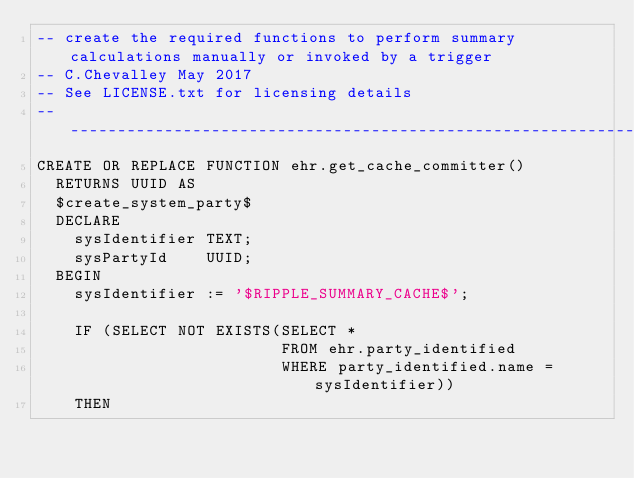Convert code to text. <code><loc_0><loc_0><loc_500><loc_500><_SQL_>-- create the required functions to perform summary calculations manually or invoked by a trigger
-- C.Chevalley May 2017
-- See LICENSE.txt for licensing details
-------------------------------------------------------------------------------------------------
CREATE OR REPLACE FUNCTION ehr.get_cache_committer()
  RETURNS UUID AS
  $create_system_party$
  DECLARE
    sysIdentifier TEXT;
    sysPartyId    UUID;
  BEGIN
    sysIdentifier := '$RIPPLE_SUMMARY_CACHE$';

    IF (SELECT NOT EXISTS(SELECT *
                          FROM ehr.party_identified
                          WHERE party_identified.name = sysIdentifier))
    THEN</code> 